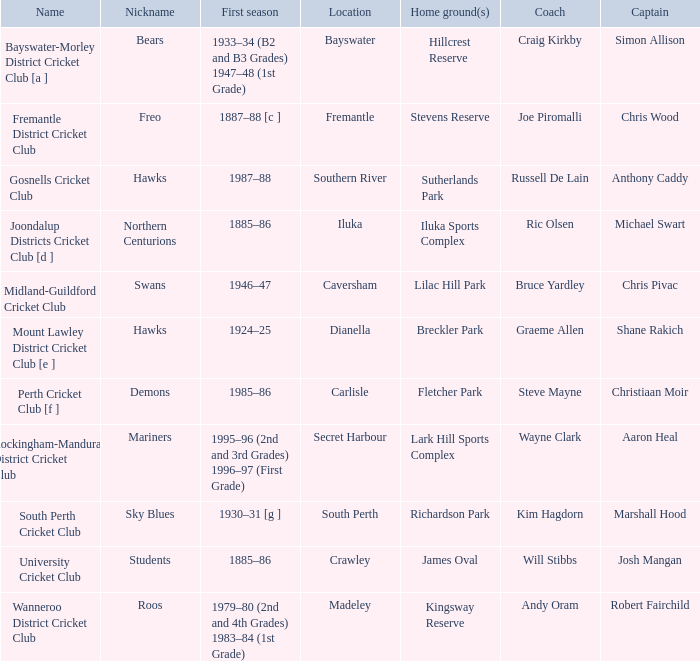Can you parse all the data within this table? {'header': ['Name', 'Nickname', 'First season', 'Location', 'Home ground(s)', 'Coach', 'Captain'], 'rows': [['Bayswater-Morley District Cricket Club [a ]', 'Bears', '1933–34 (B2 and B3 Grades) 1947–48 (1st Grade)', 'Bayswater', 'Hillcrest Reserve', 'Craig Kirkby', 'Simon Allison'], ['Fremantle District Cricket Club', 'Freo', '1887–88 [c ]', 'Fremantle', 'Stevens Reserve', 'Joe Piromalli', 'Chris Wood'], ['Gosnells Cricket Club', 'Hawks', '1987–88', 'Southern River', 'Sutherlands Park', 'Russell De Lain', 'Anthony Caddy'], ['Joondalup Districts Cricket Club [d ]', 'Northern Centurions', '1885–86', 'Iluka', 'Iluka Sports Complex', 'Ric Olsen', 'Michael Swart'], ['Midland-Guildford Cricket Club', 'Swans', '1946–47', 'Caversham', 'Lilac Hill Park', 'Bruce Yardley', 'Chris Pivac'], ['Mount Lawley District Cricket Club [e ]', 'Hawks', '1924–25', 'Dianella', 'Breckler Park', 'Graeme Allen', 'Shane Rakich'], ['Perth Cricket Club [f ]', 'Demons', '1985–86', 'Carlisle', 'Fletcher Park', 'Steve Mayne', 'Christiaan Moir'], ['Rockingham-Mandurah District Cricket Club', 'Mariners', '1995–96 (2nd and 3rd Grades) 1996–97 (First Grade)', 'Secret Harbour', 'Lark Hill Sports Complex', 'Wayne Clark', 'Aaron Heal'], ['South Perth Cricket Club', 'Sky Blues', '1930–31 [g ]', 'South Perth', 'Richardson Park', 'Kim Hagdorn', 'Marshall Hood'], ['University Cricket Club', 'Students', '1885–86', 'Crawley', 'James Oval', 'Will Stibbs', 'Josh Mangan'], ['Wanneroo District Cricket Club', 'Roos', '1979–80 (2nd and 4th Grades) 1983–84 (1st Grade)', 'Madeley', 'Kingsway Reserve', 'Andy Oram', 'Robert Fairchild']]} In which place is the bears club situated? Bayswater. 